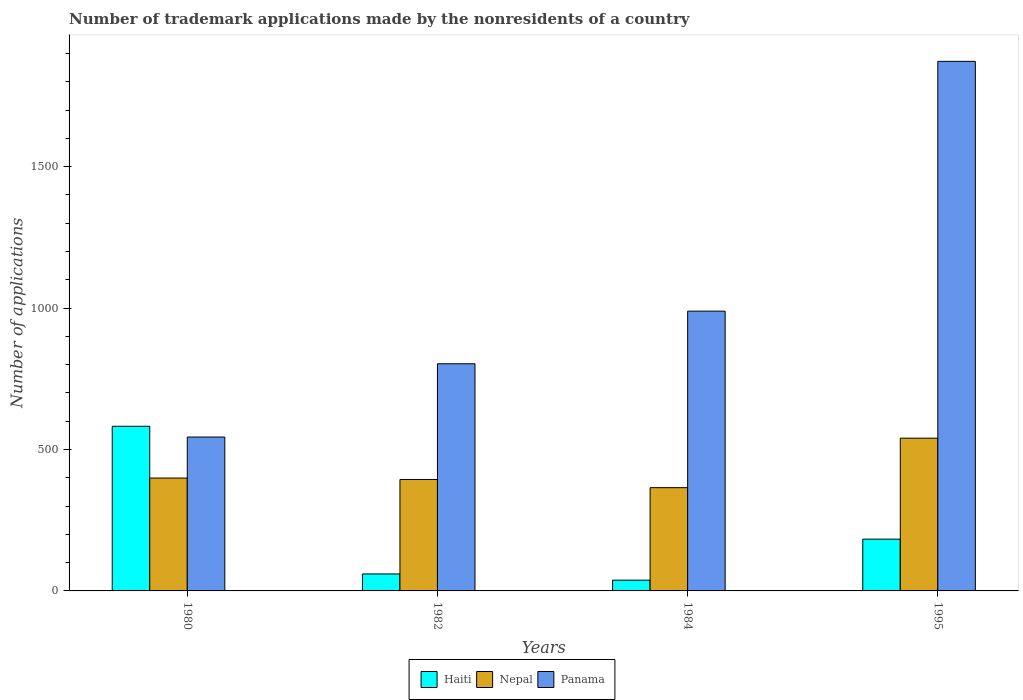How many different coloured bars are there?
Make the answer very short. 3. Are the number of bars per tick equal to the number of legend labels?
Give a very brief answer. Yes. Are the number of bars on each tick of the X-axis equal?
Offer a terse response. Yes. How many bars are there on the 3rd tick from the right?
Ensure brevity in your answer.  3. What is the label of the 4th group of bars from the left?
Your response must be concise. 1995. What is the number of trademark applications made by the nonresidents in Panama in 1995?
Provide a short and direct response. 1872. Across all years, what is the maximum number of trademark applications made by the nonresidents in Haiti?
Your answer should be compact. 582. Across all years, what is the minimum number of trademark applications made by the nonresidents in Panama?
Offer a terse response. 544. What is the total number of trademark applications made by the nonresidents in Panama in the graph?
Provide a short and direct response. 4208. What is the difference between the number of trademark applications made by the nonresidents in Haiti in 1984 and the number of trademark applications made by the nonresidents in Panama in 1980?
Make the answer very short. -506. What is the average number of trademark applications made by the nonresidents in Haiti per year?
Offer a very short reply. 215.75. In the year 1980, what is the difference between the number of trademark applications made by the nonresidents in Haiti and number of trademark applications made by the nonresidents in Nepal?
Offer a very short reply. 183. In how many years, is the number of trademark applications made by the nonresidents in Haiti greater than 400?
Offer a very short reply. 1. What is the ratio of the number of trademark applications made by the nonresidents in Haiti in 1982 to that in 1995?
Give a very brief answer. 0.33. Is the number of trademark applications made by the nonresidents in Nepal in 1980 less than that in 1995?
Give a very brief answer. Yes. Is the difference between the number of trademark applications made by the nonresidents in Haiti in 1980 and 1984 greater than the difference between the number of trademark applications made by the nonresidents in Nepal in 1980 and 1984?
Offer a terse response. Yes. What is the difference between the highest and the second highest number of trademark applications made by the nonresidents in Nepal?
Provide a short and direct response. 141. What is the difference between the highest and the lowest number of trademark applications made by the nonresidents in Nepal?
Keep it short and to the point. 175. What does the 1st bar from the left in 1982 represents?
Ensure brevity in your answer.  Haiti. What does the 1st bar from the right in 1984 represents?
Your answer should be very brief. Panama. Is it the case that in every year, the sum of the number of trademark applications made by the nonresidents in Haiti and number of trademark applications made by the nonresidents in Nepal is greater than the number of trademark applications made by the nonresidents in Panama?
Give a very brief answer. No. What is the difference between two consecutive major ticks on the Y-axis?
Offer a very short reply. 500. Does the graph contain any zero values?
Your answer should be compact. No. Does the graph contain grids?
Offer a very short reply. No. Where does the legend appear in the graph?
Your answer should be compact. Bottom center. What is the title of the graph?
Offer a terse response. Number of trademark applications made by the nonresidents of a country. What is the label or title of the X-axis?
Give a very brief answer. Years. What is the label or title of the Y-axis?
Ensure brevity in your answer.  Number of applications. What is the Number of applications in Haiti in 1980?
Keep it short and to the point. 582. What is the Number of applications in Nepal in 1980?
Make the answer very short. 399. What is the Number of applications of Panama in 1980?
Provide a succinct answer. 544. What is the Number of applications in Nepal in 1982?
Your answer should be very brief. 394. What is the Number of applications in Panama in 1982?
Offer a very short reply. 803. What is the Number of applications in Haiti in 1984?
Keep it short and to the point. 38. What is the Number of applications in Nepal in 1984?
Give a very brief answer. 365. What is the Number of applications in Panama in 1984?
Your answer should be compact. 989. What is the Number of applications in Haiti in 1995?
Provide a short and direct response. 183. What is the Number of applications in Nepal in 1995?
Offer a very short reply. 540. What is the Number of applications of Panama in 1995?
Give a very brief answer. 1872. Across all years, what is the maximum Number of applications of Haiti?
Offer a terse response. 582. Across all years, what is the maximum Number of applications in Nepal?
Keep it short and to the point. 540. Across all years, what is the maximum Number of applications in Panama?
Make the answer very short. 1872. Across all years, what is the minimum Number of applications of Nepal?
Your response must be concise. 365. Across all years, what is the minimum Number of applications of Panama?
Your answer should be compact. 544. What is the total Number of applications of Haiti in the graph?
Your response must be concise. 863. What is the total Number of applications of Nepal in the graph?
Provide a succinct answer. 1698. What is the total Number of applications of Panama in the graph?
Offer a very short reply. 4208. What is the difference between the Number of applications in Haiti in 1980 and that in 1982?
Give a very brief answer. 522. What is the difference between the Number of applications of Panama in 1980 and that in 1982?
Give a very brief answer. -259. What is the difference between the Number of applications in Haiti in 1980 and that in 1984?
Your answer should be very brief. 544. What is the difference between the Number of applications in Panama in 1980 and that in 1984?
Keep it short and to the point. -445. What is the difference between the Number of applications in Haiti in 1980 and that in 1995?
Your answer should be very brief. 399. What is the difference between the Number of applications in Nepal in 1980 and that in 1995?
Your response must be concise. -141. What is the difference between the Number of applications in Panama in 1980 and that in 1995?
Keep it short and to the point. -1328. What is the difference between the Number of applications of Nepal in 1982 and that in 1984?
Provide a short and direct response. 29. What is the difference between the Number of applications in Panama in 1982 and that in 1984?
Offer a very short reply. -186. What is the difference between the Number of applications in Haiti in 1982 and that in 1995?
Ensure brevity in your answer.  -123. What is the difference between the Number of applications in Nepal in 1982 and that in 1995?
Ensure brevity in your answer.  -146. What is the difference between the Number of applications of Panama in 1982 and that in 1995?
Ensure brevity in your answer.  -1069. What is the difference between the Number of applications of Haiti in 1984 and that in 1995?
Provide a short and direct response. -145. What is the difference between the Number of applications of Nepal in 1984 and that in 1995?
Give a very brief answer. -175. What is the difference between the Number of applications of Panama in 1984 and that in 1995?
Provide a short and direct response. -883. What is the difference between the Number of applications of Haiti in 1980 and the Number of applications of Nepal in 1982?
Keep it short and to the point. 188. What is the difference between the Number of applications in Haiti in 1980 and the Number of applications in Panama in 1982?
Your response must be concise. -221. What is the difference between the Number of applications of Nepal in 1980 and the Number of applications of Panama in 1982?
Provide a short and direct response. -404. What is the difference between the Number of applications in Haiti in 1980 and the Number of applications in Nepal in 1984?
Offer a terse response. 217. What is the difference between the Number of applications of Haiti in 1980 and the Number of applications of Panama in 1984?
Offer a terse response. -407. What is the difference between the Number of applications of Nepal in 1980 and the Number of applications of Panama in 1984?
Provide a succinct answer. -590. What is the difference between the Number of applications of Haiti in 1980 and the Number of applications of Nepal in 1995?
Ensure brevity in your answer.  42. What is the difference between the Number of applications of Haiti in 1980 and the Number of applications of Panama in 1995?
Your answer should be compact. -1290. What is the difference between the Number of applications in Nepal in 1980 and the Number of applications in Panama in 1995?
Ensure brevity in your answer.  -1473. What is the difference between the Number of applications of Haiti in 1982 and the Number of applications of Nepal in 1984?
Your response must be concise. -305. What is the difference between the Number of applications of Haiti in 1982 and the Number of applications of Panama in 1984?
Your response must be concise. -929. What is the difference between the Number of applications in Nepal in 1982 and the Number of applications in Panama in 1984?
Keep it short and to the point. -595. What is the difference between the Number of applications in Haiti in 1982 and the Number of applications in Nepal in 1995?
Your response must be concise. -480. What is the difference between the Number of applications of Haiti in 1982 and the Number of applications of Panama in 1995?
Make the answer very short. -1812. What is the difference between the Number of applications in Nepal in 1982 and the Number of applications in Panama in 1995?
Your response must be concise. -1478. What is the difference between the Number of applications of Haiti in 1984 and the Number of applications of Nepal in 1995?
Provide a short and direct response. -502. What is the difference between the Number of applications in Haiti in 1984 and the Number of applications in Panama in 1995?
Provide a succinct answer. -1834. What is the difference between the Number of applications of Nepal in 1984 and the Number of applications of Panama in 1995?
Keep it short and to the point. -1507. What is the average Number of applications of Haiti per year?
Your answer should be compact. 215.75. What is the average Number of applications of Nepal per year?
Provide a succinct answer. 424.5. What is the average Number of applications in Panama per year?
Make the answer very short. 1052. In the year 1980, what is the difference between the Number of applications of Haiti and Number of applications of Nepal?
Offer a very short reply. 183. In the year 1980, what is the difference between the Number of applications in Nepal and Number of applications in Panama?
Your answer should be compact. -145. In the year 1982, what is the difference between the Number of applications in Haiti and Number of applications in Nepal?
Give a very brief answer. -334. In the year 1982, what is the difference between the Number of applications in Haiti and Number of applications in Panama?
Your answer should be very brief. -743. In the year 1982, what is the difference between the Number of applications of Nepal and Number of applications of Panama?
Provide a short and direct response. -409. In the year 1984, what is the difference between the Number of applications of Haiti and Number of applications of Nepal?
Offer a terse response. -327. In the year 1984, what is the difference between the Number of applications of Haiti and Number of applications of Panama?
Offer a terse response. -951. In the year 1984, what is the difference between the Number of applications of Nepal and Number of applications of Panama?
Offer a terse response. -624. In the year 1995, what is the difference between the Number of applications in Haiti and Number of applications in Nepal?
Provide a succinct answer. -357. In the year 1995, what is the difference between the Number of applications of Haiti and Number of applications of Panama?
Give a very brief answer. -1689. In the year 1995, what is the difference between the Number of applications in Nepal and Number of applications in Panama?
Ensure brevity in your answer.  -1332. What is the ratio of the Number of applications of Nepal in 1980 to that in 1982?
Your answer should be compact. 1.01. What is the ratio of the Number of applications in Panama in 1980 to that in 1982?
Provide a succinct answer. 0.68. What is the ratio of the Number of applications of Haiti in 1980 to that in 1984?
Your answer should be very brief. 15.32. What is the ratio of the Number of applications of Nepal in 1980 to that in 1984?
Your answer should be very brief. 1.09. What is the ratio of the Number of applications of Panama in 1980 to that in 1984?
Provide a succinct answer. 0.55. What is the ratio of the Number of applications in Haiti in 1980 to that in 1995?
Ensure brevity in your answer.  3.18. What is the ratio of the Number of applications of Nepal in 1980 to that in 1995?
Offer a terse response. 0.74. What is the ratio of the Number of applications of Panama in 1980 to that in 1995?
Make the answer very short. 0.29. What is the ratio of the Number of applications in Haiti in 1982 to that in 1984?
Offer a very short reply. 1.58. What is the ratio of the Number of applications in Nepal in 1982 to that in 1984?
Provide a succinct answer. 1.08. What is the ratio of the Number of applications in Panama in 1982 to that in 1984?
Offer a terse response. 0.81. What is the ratio of the Number of applications of Haiti in 1982 to that in 1995?
Make the answer very short. 0.33. What is the ratio of the Number of applications in Nepal in 1982 to that in 1995?
Keep it short and to the point. 0.73. What is the ratio of the Number of applications in Panama in 1982 to that in 1995?
Give a very brief answer. 0.43. What is the ratio of the Number of applications of Haiti in 1984 to that in 1995?
Give a very brief answer. 0.21. What is the ratio of the Number of applications of Nepal in 1984 to that in 1995?
Provide a succinct answer. 0.68. What is the ratio of the Number of applications in Panama in 1984 to that in 1995?
Provide a short and direct response. 0.53. What is the difference between the highest and the second highest Number of applications in Haiti?
Your answer should be very brief. 399. What is the difference between the highest and the second highest Number of applications in Nepal?
Offer a very short reply. 141. What is the difference between the highest and the second highest Number of applications of Panama?
Provide a short and direct response. 883. What is the difference between the highest and the lowest Number of applications in Haiti?
Your answer should be compact. 544. What is the difference between the highest and the lowest Number of applications in Nepal?
Keep it short and to the point. 175. What is the difference between the highest and the lowest Number of applications of Panama?
Your response must be concise. 1328. 